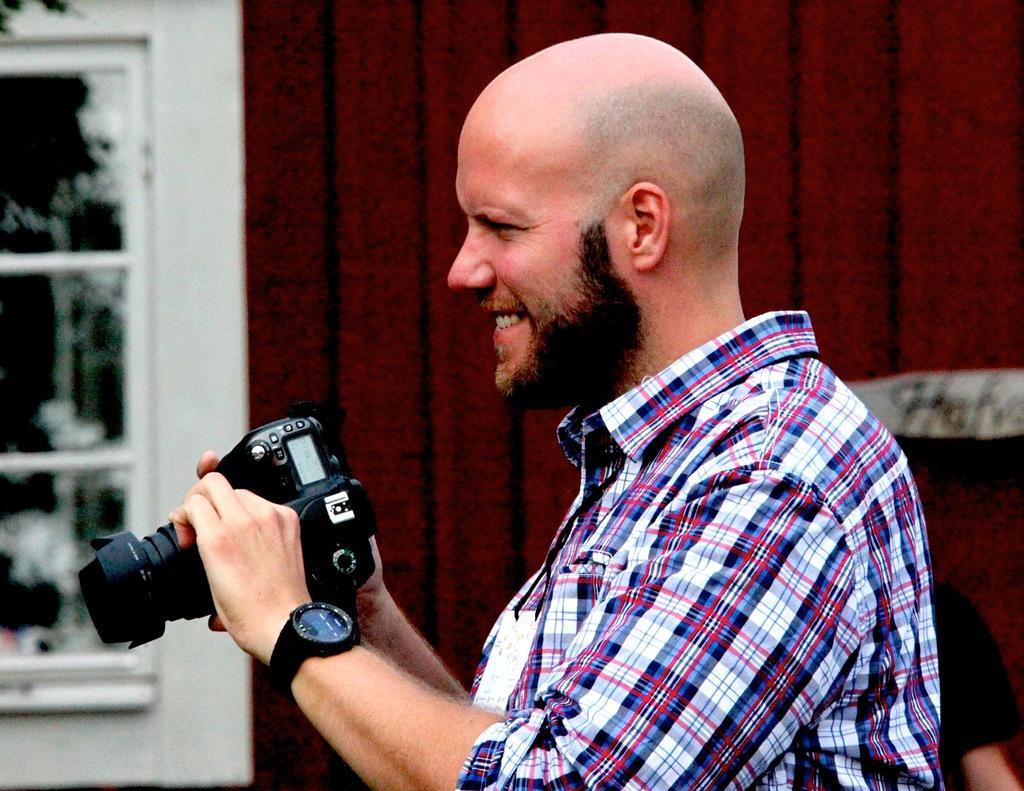Can you describe this image briefly? A man is standing by holding a camera in his hands He is smiling he wears a good shirt. 